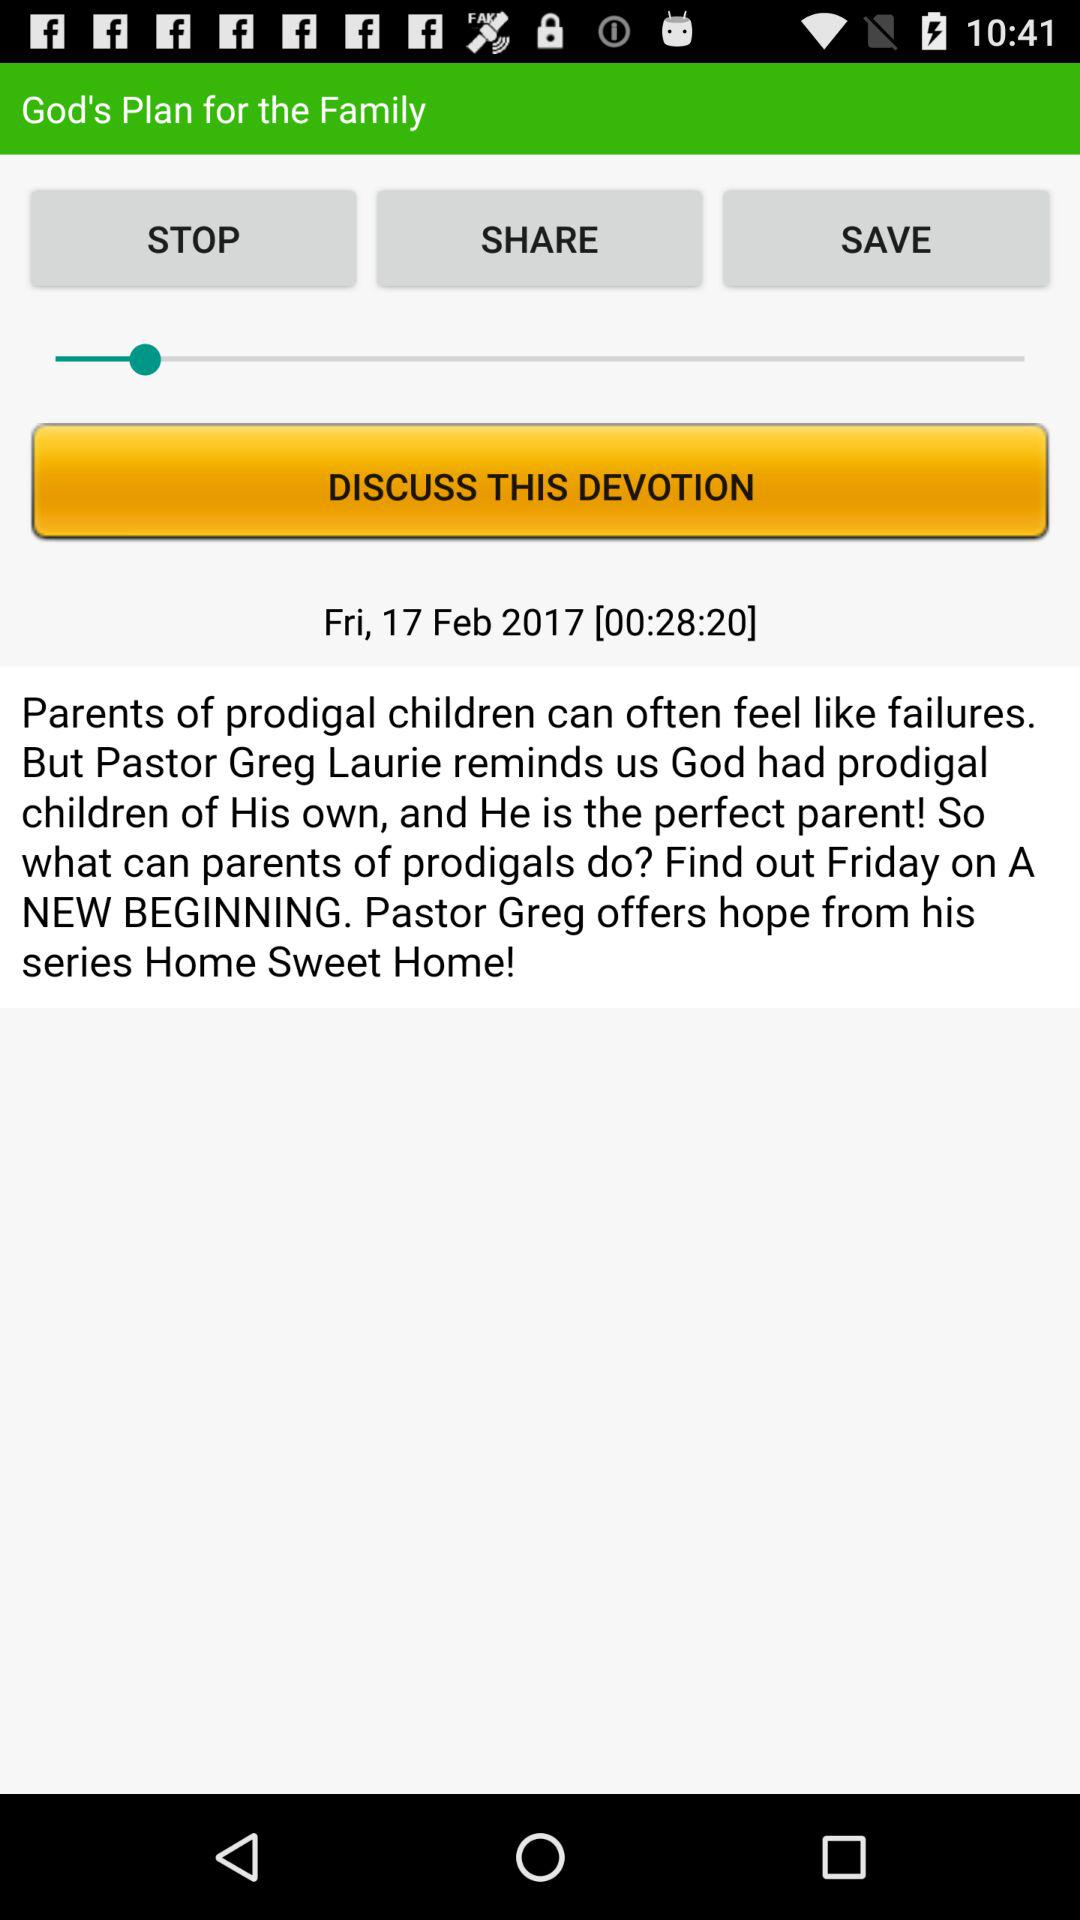Which date is displayed on the screen? The displayed date is Friday, February 17, 2017. 